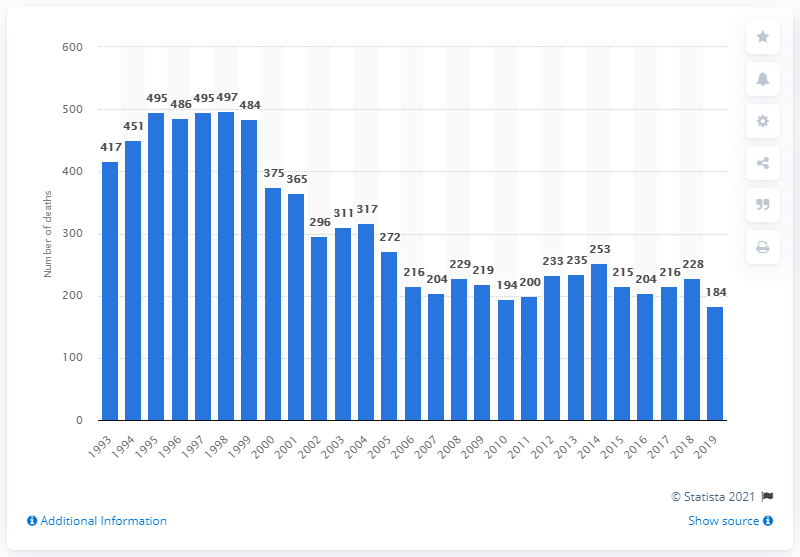Mention a couple of crucial points in this snapshot. In 1998, a total of 497 deaths were caused by tricyclic antidepressants. The largest number of deaths caused by tricyclic antidepressants was recorded in 1998. In 2019, a total of 184 deaths were attributed to tricyclic antidepressants. 